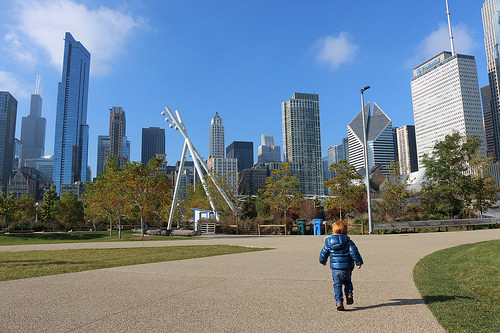<image>
Is the boy next to the refuse can? No. The boy is not positioned next to the refuse can. They are located in different areas of the scene. 